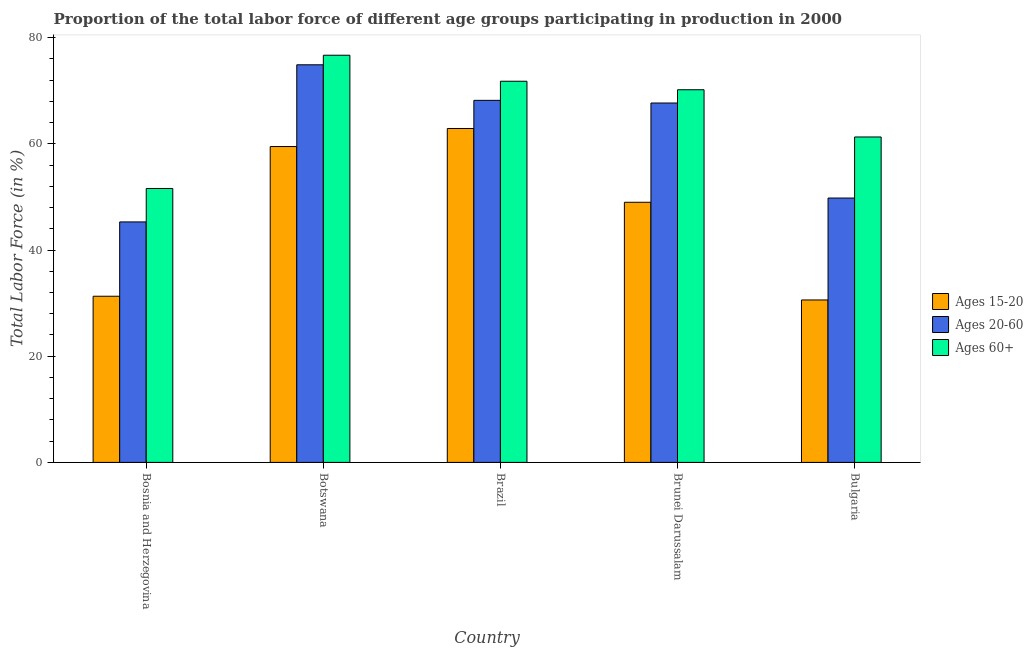How many different coloured bars are there?
Your answer should be compact. 3. How many groups of bars are there?
Provide a succinct answer. 5. Are the number of bars per tick equal to the number of legend labels?
Provide a short and direct response. Yes. How many bars are there on the 4th tick from the left?
Keep it short and to the point. 3. How many bars are there on the 4th tick from the right?
Provide a short and direct response. 3. In how many cases, is the number of bars for a given country not equal to the number of legend labels?
Provide a short and direct response. 0. What is the percentage of labor force within the age group 15-20 in Botswana?
Your answer should be compact. 59.5. Across all countries, what is the maximum percentage of labor force within the age group 15-20?
Make the answer very short. 62.9. Across all countries, what is the minimum percentage of labor force above age 60?
Your answer should be compact. 51.6. In which country was the percentage of labor force above age 60 maximum?
Offer a terse response. Botswana. In which country was the percentage of labor force within the age group 15-20 minimum?
Keep it short and to the point. Bulgaria. What is the total percentage of labor force within the age group 20-60 in the graph?
Provide a short and direct response. 305.9. What is the difference between the percentage of labor force within the age group 20-60 in Brazil and that in Bulgaria?
Make the answer very short. 18.4. What is the difference between the percentage of labor force within the age group 20-60 in Brunei Darussalam and the percentage of labor force within the age group 15-20 in Bulgaria?
Your response must be concise. 37.1. What is the average percentage of labor force within the age group 20-60 per country?
Your response must be concise. 61.18. What is the difference between the percentage of labor force within the age group 20-60 and percentage of labor force within the age group 15-20 in Brunei Darussalam?
Your answer should be very brief. 18.7. In how many countries, is the percentage of labor force within the age group 15-20 greater than 60 %?
Make the answer very short. 1. What is the ratio of the percentage of labor force above age 60 in Brazil to that in Brunei Darussalam?
Offer a very short reply. 1.02. What is the difference between the highest and the second highest percentage of labor force within the age group 20-60?
Your answer should be very brief. 6.7. What is the difference between the highest and the lowest percentage of labor force within the age group 20-60?
Keep it short and to the point. 29.6. In how many countries, is the percentage of labor force above age 60 greater than the average percentage of labor force above age 60 taken over all countries?
Offer a terse response. 3. Is the sum of the percentage of labor force within the age group 20-60 in Botswana and Bulgaria greater than the maximum percentage of labor force within the age group 15-20 across all countries?
Your answer should be compact. Yes. What does the 2nd bar from the left in Botswana represents?
Your response must be concise. Ages 20-60. What does the 3rd bar from the right in Bulgaria represents?
Keep it short and to the point. Ages 15-20. How many bars are there?
Offer a very short reply. 15. Are all the bars in the graph horizontal?
Ensure brevity in your answer.  No. How many countries are there in the graph?
Offer a very short reply. 5. What is the difference between two consecutive major ticks on the Y-axis?
Offer a terse response. 20. Are the values on the major ticks of Y-axis written in scientific E-notation?
Provide a short and direct response. No. Does the graph contain any zero values?
Your answer should be very brief. No. Where does the legend appear in the graph?
Your response must be concise. Center right. How many legend labels are there?
Your answer should be very brief. 3. How are the legend labels stacked?
Give a very brief answer. Vertical. What is the title of the graph?
Keep it short and to the point. Proportion of the total labor force of different age groups participating in production in 2000. What is the label or title of the X-axis?
Make the answer very short. Country. What is the label or title of the Y-axis?
Your answer should be very brief. Total Labor Force (in %). What is the Total Labor Force (in %) of Ages 15-20 in Bosnia and Herzegovina?
Provide a short and direct response. 31.3. What is the Total Labor Force (in %) of Ages 20-60 in Bosnia and Herzegovina?
Ensure brevity in your answer.  45.3. What is the Total Labor Force (in %) of Ages 60+ in Bosnia and Herzegovina?
Keep it short and to the point. 51.6. What is the Total Labor Force (in %) in Ages 15-20 in Botswana?
Your response must be concise. 59.5. What is the Total Labor Force (in %) in Ages 20-60 in Botswana?
Provide a succinct answer. 74.9. What is the Total Labor Force (in %) in Ages 60+ in Botswana?
Ensure brevity in your answer.  76.7. What is the Total Labor Force (in %) in Ages 15-20 in Brazil?
Offer a terse response. 62.9. What is the Total Labor Force (in %) of Ages 20-60 in Brazil?
Your answer should be compact. 68.2. What is the Total Labor Force (in %) in Ages 60+ in Brazil?
Offer a very short reply. 71.8. What is the Total Labor Force (in %) in Ages 20-60 in Brunei Darussalam?
Your answer should be very brief. 67.7. What is the Total Labor Force (in %) in Ages 60+ in Brunei Darussalam?
Provide a succinct answer. 70.2. What is the Total Labor Force (in %) of Ages 15-20 in Bulgaria?
Offer a very short reply. 30.6. What is the Total Labor Force (in %) in Ages 20-60 in Bulgaria?
Provide a succinct answer. 49.8. What is the Total Labor Force (in %) of Ages 60+ in Bulgaria?
Make the answer very short. 61.3. Across all countries, what is the maximum Total Labor Force (in %) in Ages 15-20?
Make the answer very short. 62.9. Across all countries, what is the maximum Total Labor Force (in %) of Ages 20-60?
Make the answer very short. 74.9. Across all countries, what is the maximum Total Labor Force (in %) in Ages 60+?
Offer a terse response. 76.7. Across all countries, what is the minimum Total Labor Force (in %) in Ages 15-20?
Your response must be concise. 30.6. Across all countries, what is the minimum Total Labor Force (in %) of Ages 20-60?
Keep it short and to the point. 45.3. Across all countries, what is the minimum Total Labor Force (in %) of Ages 60+?
Give a very brief answer. 51.6. What is the total Total Labor Force (in %) of Ages 15-20 in the graph?
Your response must be concise. 233.3. What is the total Total Labor Force (in %) in Ages 20-60 in the graph?
Ensure brevity in your answer.  305.9. What is the total Total Labor Force (in %) of Ages 60+ in the graph?
Provide a short and direct response. 331.6. What is the difference between the Total Labor Force (in %) in Ages 15-20 in Bosnia and Herzegovina and that in Botswana?
Your response must be concise. -28.2. What is the difference between the Total Labor Force (in %) of Ages 20-60 in Bosnia and Herzegovina and that in Botswana?
Make the answer very short. -29.6. What is the difference between the Total Labor Force (in %) of Ages 60+ in Bosnia and Herzegovina and that in Botswana?
Your answer should be compact. -25.1. What is the difference between the Total Labor Force (in %) of Ages 15-20 in Bosnia and Herzegovina and that in Brazil?
Provide a succinct answer. -31.6. What is the difference between the Total Labor Force (in %) in Ages 20-60 in Bosnia and Herzegovina and that in Brazil?
Provide a short and direct response. -22.9. What is the difference between the Total Labor Force (in %) in Ages 60+ in Bosnia and Herzegovina and that in Brazil?
Give a very brief answer. -20.2. What is the difference between the Total Labor Force (in %) in Ages 15-20 in Bosnia and Herzegovina and that in Brunei Darussalam?
Give a very brief answer. -17.7. What is the difference between the Total Labor Force (in %) in Ages 20-60 in Bosnia and Herzegovina and that in Brunei Darussalam?
Give a very brief answer. -22.4. What is the difference between the Total Labor Force (in %) in Ages 60+ in Bosnia and Herzegovina and that in Brunei Darussalam?
Your answer should be very brief. -18.6. What is the difference between the Total Labor Force (in %) of Ages 15-20 in Bosnia and Herzegovina and that in Bulgaria?
Offer a very short reply. 0.7. What is the difference between the Total Labor Force (in %) of Ages 60+ in Bosnia and Herzegovina and that in Bulgaria?
Provide a short and direct response. -9.7. What is the difference between the Total Labor Force (in %) of Ages 20-60 in Botswana and that in Brazil?
Your answer should be very brief. 6.7. What is the difference between the Total Labor Force (in %) of Ages 60+ in Botswana and that in Brazil?
Offer a very short reply. 4.9. What is the difference between the Total Labor Force (in %) in Ages 15-20 in Botswana and that in Brunei Darussalam?
Provide a short and direct response. 10.5. What is the difference between the Total Labor Force (in %) of Ages 15-20 in Botswana and that in Bulgaria?
Ensure brevity in your answer.  28.9. What is the difference between the Total Labor Force (in %) of Ages 20-60 in Botswana and that in Bulgaria?
Provide a succinct answer. 25.1. What is the difference between the Total Labor Force (in %) of Ages 60+ in Botswana and that in Bulgaria?
Provide a short and direct response. 15.4. What is the difference between the Total Labor Force (in %) in Ages 20-60 in Brazil and that in Brunei Darussalam?
Ensure brevity in your answer.  0.5. What is the difference between the Total Labor Force (in %) of Ages 15-20 in Brazil and that in Bulgaria?
Your response must be concise. 32.3. What is the difference between the Total Labor Force (in %) of Ages 20-60 in Brazil and that in Bulgaria?
Offer a very short reply. 18.4. What is the difference between the Total Labor Force (in %) of Ages 60+ in Brunei Darussalam and that in Bulgaria?
Offer a very short reply. 8.9. What is the difference between the Total Labor Force (in %) of Ages 15-20 in Bosnia and Herzegovina and the Total Labor Force (in %) of Ages 20-60 in Botswana?
Keep it short and to the point. -43.6. What is the difference between the Total Labor Force (in %) in Ages 15-20 in Bosnia and Herzegovina and the Total Labor Force (in %) in Ages 60+ in Botswana?
Your answer should be compact. -45.4. What is the difference between the Total Labor Force (in %) of Ages 20-60 in Bosnia and Herzegovina and the Total Labor Force (in %) of Ages 60+ in Botswana?
Offer a terse response. -31.4. What is the difference between the Total Labor Force (in %) in Ages 15-20 in Bosnia and Herzegovina and the Total Labor Force (in %) in Ages 20-60 in Brazil?
Provide a short and direct response. -36.9. What is the difference between the Total Labor Force (in %) of Ages 15-20 in Bosnia and Herzegovina and the Total Labor Force (in %) of Ages 60+ in Brazil?
Provide a succinct answer. -40.5. What is the difference between the Total Labor Force (in %) of Ages 20-60 in Bosnia and Herzegovina and the Total Labor Force (in %) of Ages 60+ in Brazil?
Ensure brevity in your answer.  -26.5. What is the difference between the Total Labor Force (in %) of Ages 15-20 in Bosnia and Herzegovina and the Total Labor Force (in %) of Ages 20-60 in Brunei Darussalam?
Your response must be concise. -36.4. What is the difference between the Total Labor Force (in %) of Ages 15-20 in Bosnia and Herzegovina and the Total Labor Force (in %) of Ages 60+ in Brunei Darussalam?
Ensure brevity in your answer.  -38.9. What is the difference between the Total Labor Force (in %) of Ages 20-60 in Bosnia and Herzegovina and the Total Labor Force (in %) of Ages 60+ in Brunei Darussalam?
Offer a very short reply. -24.9. What is the difference between the Total Labor Force (in %) in Ages 15-20 in Bosnia and Herzegovina and the Total Labor Force (in %) in Ages 20-60 in Bulgaria?
Your answer should be very brief. -18.5. What is the difference between the Total Labor Force (in %) of Ages 20-60 in Bosnia and Herzegovina and the Total Labor Force (in %) of Ages 60+ in Bulgaria?
Your answer should be very brief. -16. What is the difference between the Total Labor Force (in %) of Ages 15-20 in Botswana and the Total Labor Force (in %) of Ages 20-60 in Brazil?
Your answer should be very brief. -8.7. What is the difference between the Total Labor Force (in %) of Ages 15-20 in Botswana and the Total Labor Force (in %) of Ages 20-60 in Brunei Darussalam?
Ensure brevity in your answer.  -8.2. What is the difference between the Total Labor Force (in %) of Ages 15-20 in Botswana and the Total Labor Force (in %) of Ages 60+ in Brunei Darussalam?
Offer a very short reply. -10.7. What is the difference between the Total Labor Force (in %) in Ages 15-20 in Botswana and the Total Labor Force (in %) in Ages 20-60 in Bulgaria?
Your response must be concise. 9.7. What is the difference between the Total Labor Force (in %) of Ages 15-20 in Botswana and the Total Labor Force (in %) of Ages 60+ in Bulgaria?
Keep it short and to the point. -1.8. What is the difference between the Total Labor Force (in %) of Ages 20-60 in Botswana and the Total Labor Force (in %) of Ages 60+ in Bulgaria?
Your response must be concise. 13.6. What is the difference between the Total Labor Force (in %) in Ages 15-20 in Brazil and the Total Labor Force (in %) in Ages 60+ in Brunei Darussalam?
Your answer should be compact. -7.3. What is the difference between the Total Labor Force (in %) in Ages 15-20 in Brazil and the Total Labor Force (in %) in Ages 20-60 in Bulgaria?
Give a very brief answer. 13.1. What is the difference between the Total Labor Force (in %) of Ages 15-20 in Brazil and the Total Labor Force (in %) of Ages 60+ in Bulgaria?
Your answer should be very brief. 1.6. What is the difference between the Total Labor Force (in %) in Ages 15-20 in Brunei Darussalam and the Total Labor Force (in %) in Ages 60+ in Bulgaria?
Offer a terse response. -12.3. What is the average Total Labor Force (in %) in Ages 15-20 per country?
Your answer should be very brief. 46.66. What is the average Total Labor Force (in %) in Ages 20-60 per country?
Ensure brevity in your answer.  61.18. What is the average Total Labor Force (in %) of Ages 60+ per country?
Provide a succinct answer. 66.32. What is the difference between the Total Labor Force (in %) of Ages 15-20 and Total Labor Force (in %) of Ages 20-60 in Bosnia and Herzegovina?
Your answer should be compact. -14. What is the difference between the Total Labor Force (in %) in Ages 15-20 and Total Labor Force (in %) in Ages 60+ in Bosnia and Herzegovina?
Provide a short and direct response. -20.3. What is the difference between the Total Labor Force (in %) of Ages 20-60 and Total Labor Force (in %) of Ages 60+ in Bosnia and Herzegovina?
Your response must be concise. -6.3. What is the difference between the Total Labor Force (in %) in Ages 15-20 and Total Labor Force (in %) in Ages 20-60 in Botswana?
Keep it short and to the point. -15.4. What is the difference between the Total Labor Force (in %) in Ages 15-20 and Total Labor Force (in %) in Ages 60+ in Botswana?
Ensure brevity in your answer.  -17.2. What is the difference between the Total Labor Force (in %) of Ages 20-60 and Total Labor Force (in %) of Ages 60+ in Botswana?
Your answer should be very brief. -1.8. What is the difference between the Total Labor Force (in %) of Ages 15-20 and Total Labor Force (in %) of Ages 20-60 in Brazil?
Give a very brief answer. -5.3. What is the difference between the Total Labor Force (in %) in Ages 15-20 and Total Labor Force (in %) in Ages 60+ in Brazil?
Provide a short and direct response. -8.9. What is the difference between the Total Labor Force (in %) in Ages 20-60 and Total Labor Force (in %) in Ages 60+ in Brazil?
Make the answer very short. -3.6. What is the difference between the Total Labor Force (in %) in Ages 15-20 and Total Labor Force (in %) in Ages 20-60 in Brunei Darussalam?
Keep it short and to the point. -18.7. What is the difference between the Total Labor Force (in %) of Ages 15-20 and Total Labor Force (in %) of Ages 60+ in Brunei Darussalam?
Ensure brevity in your answer.  -21.2. What is the difference between the Total Labor Force (in %) in Ages 15-20 and Total Labor Force (in %) in Ages 20-60 in Bulgaria?
Your answer should be compact. -19.2. What is the difference between the Total Labor Force (in %) in Ages 15-20 and Total Labor Force (in %) in Ages 60+ in Bulgaria?
Keep it short and to the point. -30.7. What is the ratio of the Total Labor Force (in %) of Ages 15-20 in Bosnia and Herzegovina to that in Botswana?
Give a very brief answer. 0.53. What is the ratio of the Total Labor Force (in %) in Ages 20-60 in Bosnia and Herzegovina to that in Botswana?
Your response must be concise. 0.6. What is the ratio of the Total Labor Force (in %) in Ages 60+ in Bosnia and Herzegovina to that in Botswana?
Keep it short and to the point. 0.67. What is the ratio of the Total Labor Force (in %) in Ages 15-20 in Bosnia and Herzegovina to that in Brazil?
Offer a very short reply. 0.5. What is the ratio of the Total Labor Force (in %) in Ages 20-60 in Bosnia and Herzegovina to that in Brazil?
Your answer should be compact. 0.66. What is the ratio of the Total Labor Force (in %) of Ages 60+ in Bosnia and Herzegovina to that in Brazil?
Provide a succinct answer. 0.72. What is the ratio of the Total Labor Force (in %) of Ages 15-20 in Bosnia and Herzegovina to that in Brunei Darussalam?
Your answer should be compact. 0.64. What is the ratio of the Total Labor Force (in %) in Ages 20-60 in Bosnia and Herzegovina to that in Brunei Darussalam?
Provide a short and direct response. 0.67. What is the ratio of the Total Labor Force (in %) of Ages 60+ in Bosnia and Herzegovina to that in Brunei Darussalam?
Your answer should be compact. 0.73. What is the ratio of the Total Labor Force (in %) of Ages 15-20 in Bosnia and Herzegovina to that in Bulgaria?
Make the answer very short. 1.02. What is the ratio of the Total Labor Force (in %) in Ages 20-60 in Bosnia and Herzegovina to that in Bulgaria?
Offer a very short reply. 0.91. What is the ratio of the Total Labor Force (in %) in Ages 60+ in Bosnia and Herzegovina to that in Bulgaria?
Make the answer very short. 0.84. What is the ratio of the Total Labor Force (in %) in Ages 15-20 in Botswana to that in Brazil?
Ensure brevity in your answer.  0.95. What is the ratio of the Total Labor Force (in %) in Ages 20-60 in Botswana to that in Brazil?
Give a very brief answer. 1.1. What is the ratio of the Total Labor Force (in %) of Ages 60+ in Botswana to that in Brazil?
Your answer should be very brief. 1.07. What is the ratio of the Total Labor Force (in %) in Ages 15-20 in Botswana to that in Brunei Darussalam?
Keep it short and to the point. 1.21. What is the ratio of the Total Labor Force (in %) of Ages 20-60 in Botswana to that in Brunei Darussalam?
Ensure brevity in your answer.  1.11. What is the ratio of the Total Labor Force (in %) in Ages 60+ in Botswana to that in Brunei Darussalam?
Make the answer very short. 1.09. What is the ratio of the Total Labor Force (in %) of Ages 15-20 in Botswana to that in Bulgaria?
Offer a very short reply. 1.94. What is the ratio of the Total Labor Force (in %) of Ages 20-60 in Botswana to that in Bulgaria?
Provide a succinct answer. 1.5. What is the ratio of the Total Labor Force (in %) of Ages 60+ in Botswana to that in Bulgaria?
Ensure brevity in your answer.  1.25. What is the ratio of the Total Labor Force (in %) in Ages 15-20 in Brazil to that in Brunei Darussalam?
Your answer should be very brief. 1.28. What is the ratio of the Total Labor Force (in %) in Ages 20-60 in Brazil to that in Brunei Darussalam?
Give a very brief answer. 1.01. What is the ratio of the Total Labor Force (in %) in Ages 60+ in Brazil to that in Brunei Darussalam?
Your response must be concise. 1.02. What is the ratio of the Total Labor Force (in %) in Ages 15-20 in Brazil to that in Bulgaria?
Offer a terse response. 2.06. What is the ratio of the Total Labor Force (in %) in Ages 20-60 in Brazil to that in Bulgaria?
Make the answer very short. 1.37. What is the ratio of the Total Labor Force (in %) in Ages 60+ in Brazil to that in Bulgaria?
Your response must be concise. 1.17. What is the ratio of the Total Labor Force (in %) of Ages 15-20 in Brunei Darussalam to that in Bulgaria?
Your response must be concise. 1.6. What is the ratio of the Total Labor Force (in %) of Ages 20-60 in Brunei Darussalam to that in Bulgaria?
Your response must be concise. 1.36. What is the ratio of the Total Labor Force (in %) of Ages 60+ in Brunei Darussalam to that in Bulgaria?
Give a very brief answer. 1.15. What is the difference between the highest and the second highest Total Labor Force (in %) of Ages 15-20?
Provide a short and direct response. 3.4. What is the difference between the highest and the second highest Total Labor Force (in %) of Ages 20-60?
Give a very brief answer. 6.7. What is the difference between the highest and the lowest Total Labor Force (in %) of Ages 15-20?
Your response must be concise. 32.3. What is the difference between the highest and the lowest Total Labor Force (in %) in Ages 20-60?
Make the answer very short. 29.6. What is the difference between the highest and the lowest Total Labor Force (in %) in Ages 60+?
Make the answer very short. 25.1. 